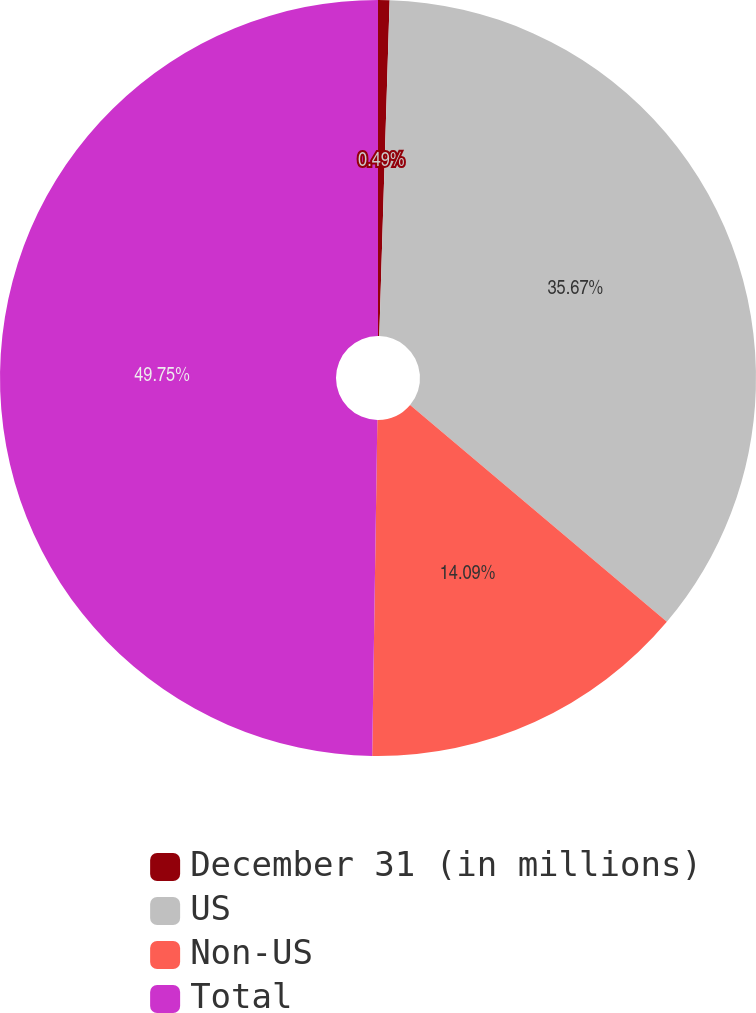Convert chart. <chart><loc_0><loc_0><loc_500><loc_500><pie_chart><fcel>December 31 (in millions)<fcel>US<fcel>Non-US<fcel>Total<nl><fcel>0.49%<fcel>35.67%<fcel>14.09%<fcel>49.76%<nl></chart> 